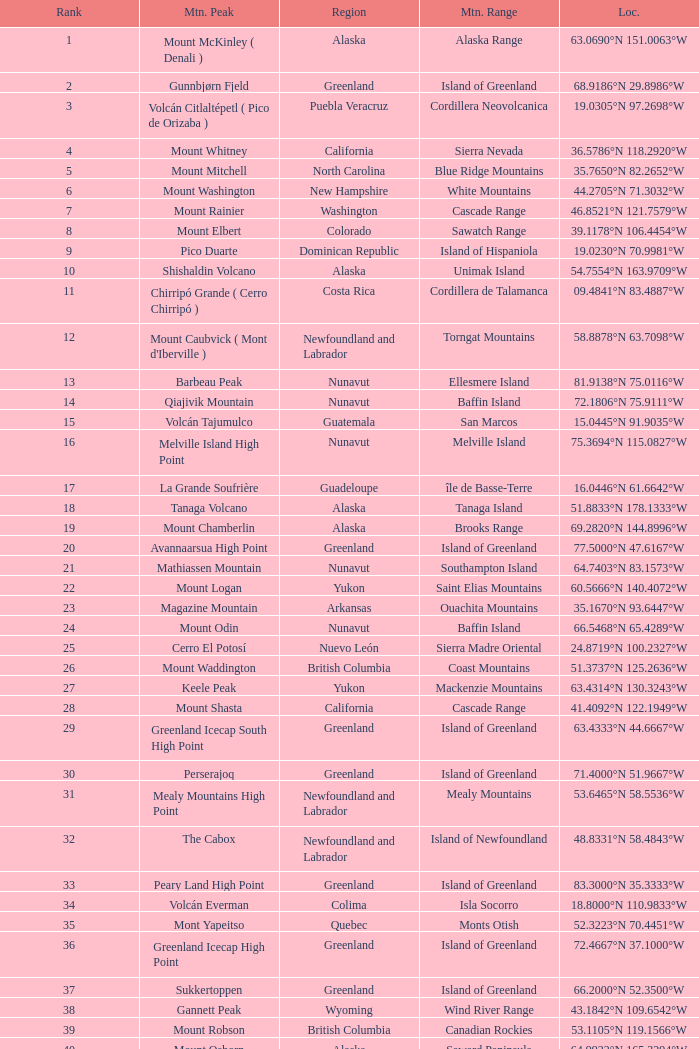Which Mountain Peak has a Region of baja california, and a Location of 28.1301°n 115.2206°w? Isla Cedros High Point. 